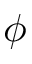<formula> <loc_0><loc_0><loc_500><loc_500>\phi</formula> 